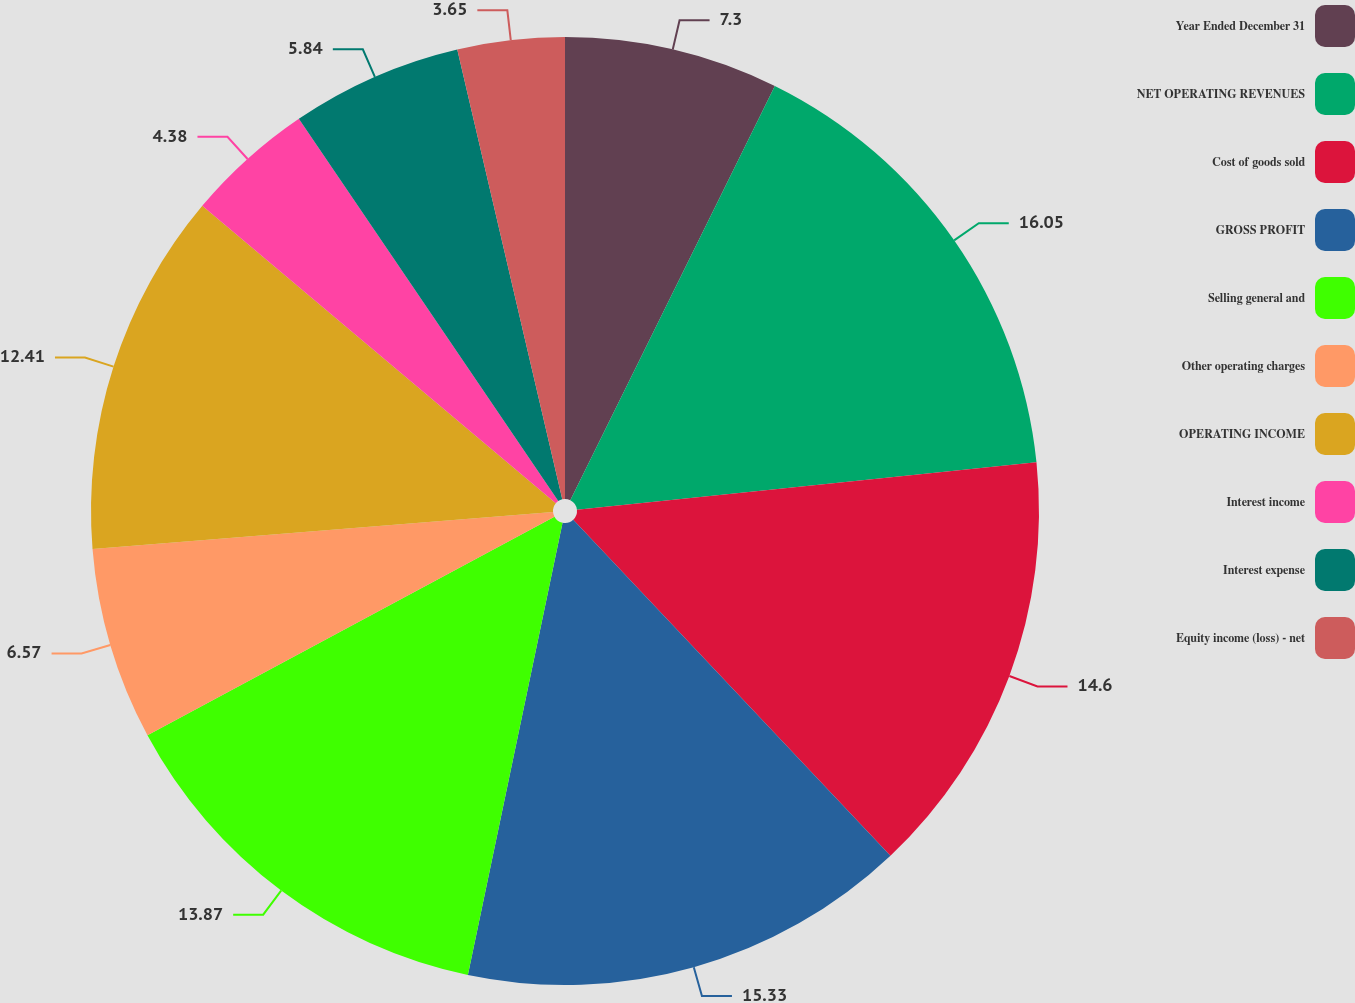<chart> <loc_0><loc_0><loc_500><loc_500><pie_chart><fcel>Year Ended December 31<fcel>NET OPERATING REVENUES<fcel>Cost of goods sold<fcel>GROSS PROFIT<fcel>Selling general and<fcel>Other operating charges<fcel>OPERATING INCOME<fcel>Interest income<fcel>Interest expense<fcel>Equity income (loss) - net<nl><fcel>7.3%<fcel>16.06%<fcel>14.6%<fcel>15.33%<fcel>13.87%<fcel>6.57%<fcel>12.41%<fcel>4.38%<fcel>5.84%<fcel>3.65%<nl></chart> 